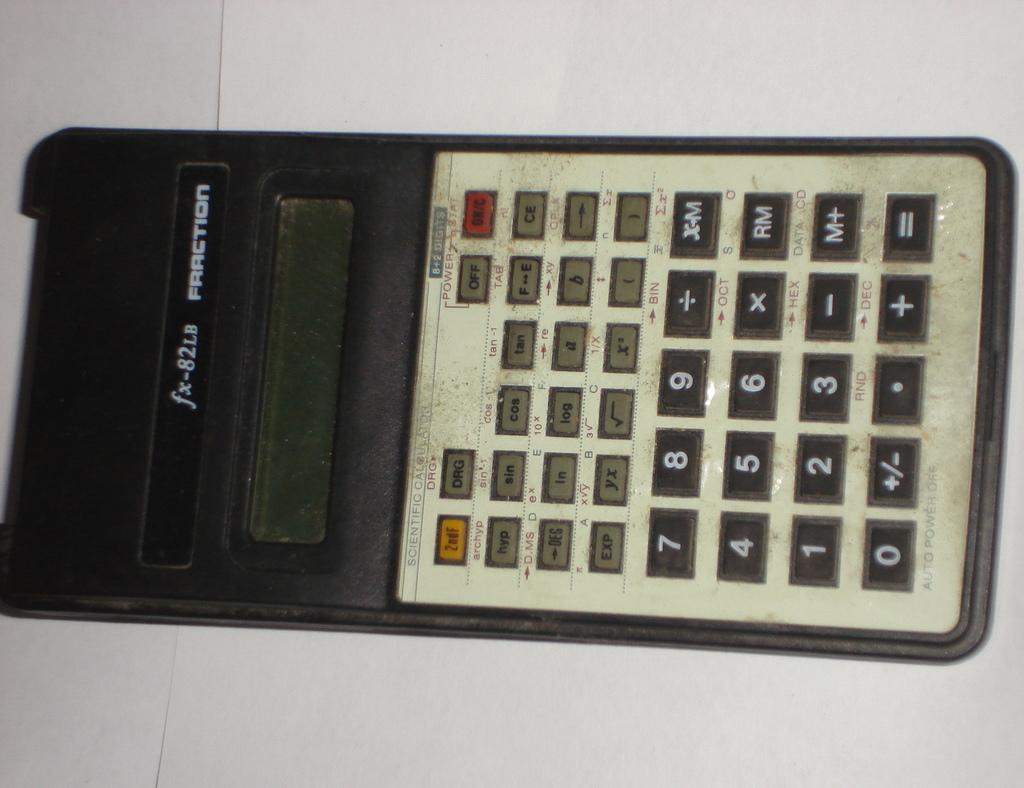<image>
Present a compact description of the photo's key features. the number 7 is on the front of the calculator 